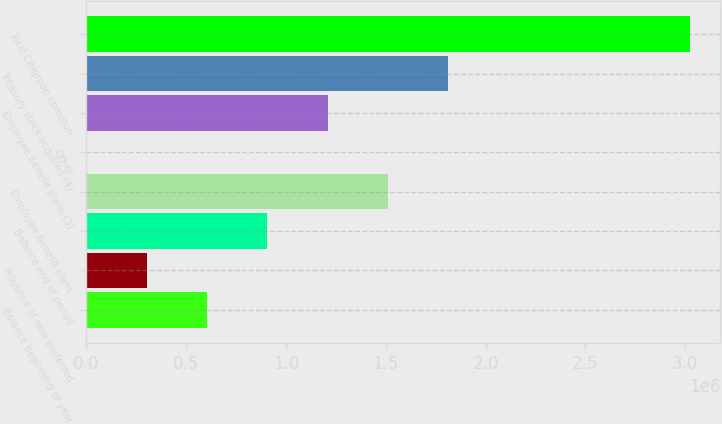Convert chart to OTSL. <chart><loc_0><loc_0><loc_500><loc_500><bar_chart><fcel>Balance beginning of year<fcel>Issuance of new preferred<fcel>Balance end of period<fcel>Employee benefit plans<fcel>Other<fcel>Employee benefit plans (3)<fcel>Treasury stock acquired (4)<fcel>Total Citigroup common<nl><fcel>604793<fcel>302402<fcel>907183<fcel>1.51196e+06<fcel>11<fcel>1.20957e+06<fcel>1.81436e+06<fcel>3.02392e+06<nl></chart> 